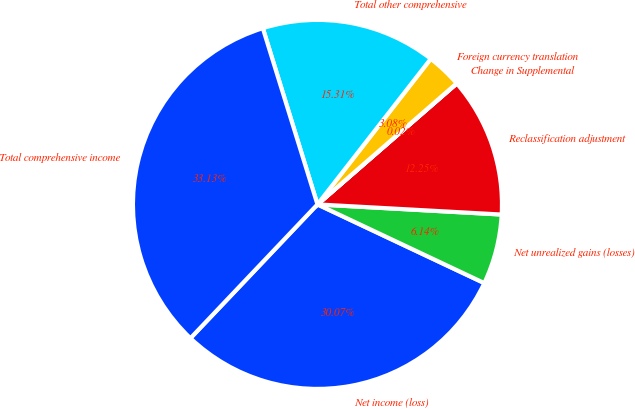Convert chart to OTSL. <chart><loc_0><loc_0><loc_500><loc_500><pie_chart><fcel>Net income (loss)<fcel>Net unrealized gains (losses)<fcel>Reclassification adjustment<fcel>Change in Supplemental<fcel>Foreign currency translation<fcel>Total other comprehensive<fcel>Total comprehensive income<nl><fcel>30.07%<fcel>6.14%<fcel>12.25%<fcel>0.02%<fcel>3.08%<fcel>15.31%<fcel>33.13%<nl></chart> 